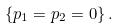<formula> <loc_0><loc_0><loc_500><loc_500>\{ p _ { 1 } = p _ { 2 } = 0 \} \, .</formula> 